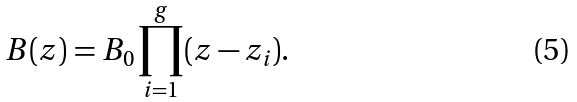Convert formula to latex. <formula><loc_0><loc_0><loc_500><loc_500>B ( z ) = B _ { 0 } \prod _ { i = 1 } ^ { g } ( z - z _ { i } ) .</formula> 